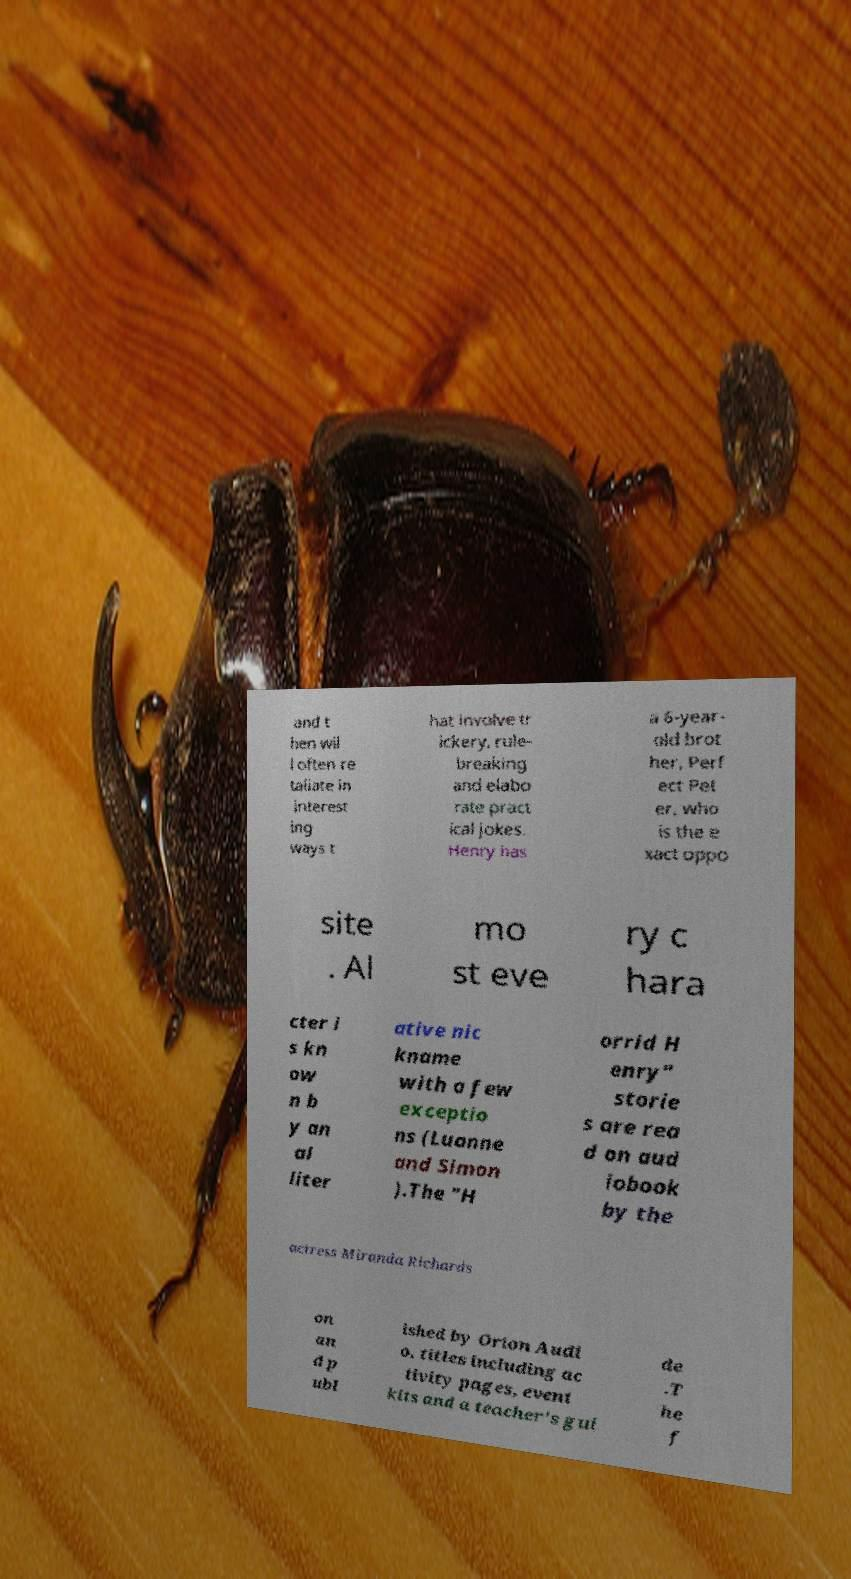Could you extract and type out the text from this image? and t hen wil l often re taliate in interest ing ways t hat involve tr ickery, rule- breaking and elabo rate pract ical jokes. Henry has a 6-year- old brot her, Perf ect Pet er, who is the e xact oppo site . Al mo st eve ry c hara cter i s kn ow n b y an al liter ative nic kname with a few exceptio ns (Luanne and Simon ).The "H orrid H enry" storie s are rea d on aud iobook by the actress Miranda Richards on an d p ubl ished by Orion Audi o. titles including ac tivity pages, event kits and a teacher's gui de .T he f 